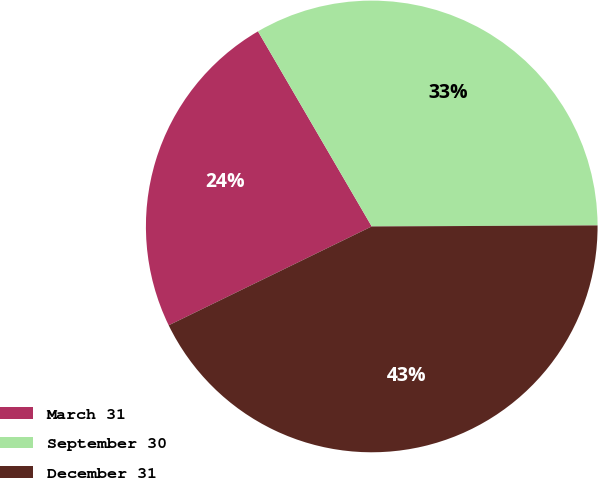Convert chart. <chart><loc_0><loc_0><loc_500><loc_500><pie_chart><fcel>March 31<fcel>September 30<fcel>December 31<nl><fcel>23.81%<fcel>33.33%<fcel>42.86%<nl></chart> 